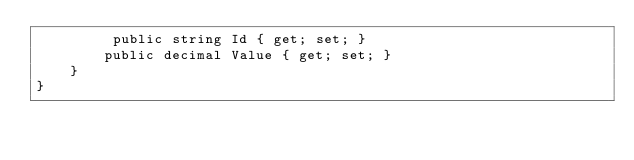Convert code to text. <code><loc_0><loc_0><loc_500><loc_500><_C#_>         public string Id { get; set; }
        public decimal Value { get; set; }
    }
}</code> 